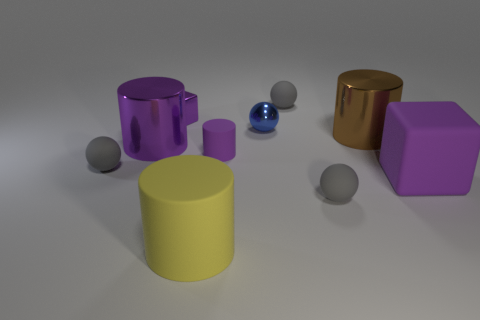There is a small thing that is behind the tiny purple thing that is behind the tiny cylinder; what is its color?
Provide a short and direct response. Gray. How many big objects are in front of the big brown cylinder and on the left side of the purple rubber block?
Your answer should be very brief. 2. There is a tiny gray sphere to the left of the tiny blue thing; what number of tiny gray rubber balls are right of it?
Your answer should be compact. 2. Is the color of the metal sphere the same as the large matte thing that is in front of the purple rubber block?
Your answer should be very brief. No. There is a cylinder that is the same size as the metallic sphere; what color is it?
Ensure brevity in your answer.  Purple. The shiny cylinder on the left side of the small blue sphere is what color?
Give a very brief answer. Purple. The object that is in front of the gray matte ball in front of the purple rubber block is what shape?
Your answer should be compact. Cylinder. Is the small purple block made of the same material as the gray object that is on the left side of the large purple metal cylinder?
Ensure brevity in your answer.  No. What is the shape of the rubber thing that is the same color as the big block?
Provide a succinct answer. Cylinder. What number of purple cylinders have the same size as the matte cube?
Provide a succinct answer. 1. 